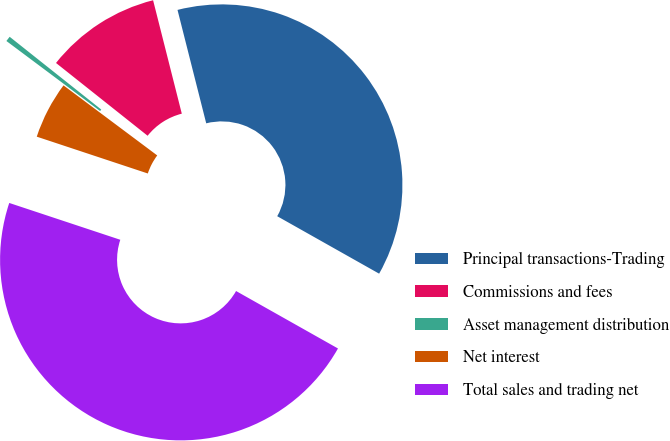Convert chart to OTSL. <chart><loc_0><loc_0><loc_500><loc_500><pie_chart><fcel>Principal transactions-Trading<fcel>Commissions and fees<fcel>Asset management distribution<fcel>Net interest<fcel>Total sales and trading net<nl><fcel>37.12%<fcel>10.37%<fcel>0.47%<fcel>5.12%<fcel>46.93%<nl></chart> 